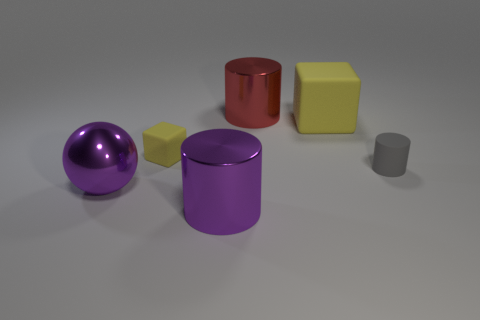Subtract all large shiny cylinders. How many cylinders are left? 1 Add 1 gray cylinders. How many objects exist? 7 Subtract all spheres. How many objects are left? 5 Subtract 2 cylinders. How many cylinders are left? 1 Subtract all green cubes. Subtract all red cylinders. How many cubes are left? 2 Subtract all gray blocks. Subtract all big purple metal objects. How many objects are left? 4 Add 3 large rubber cubes. How many large rubber cubes are left? 4 Add 3 spheres. How many spheres exist? 4 Subtract 0 cyan cylinders. How many objects are left? 6 